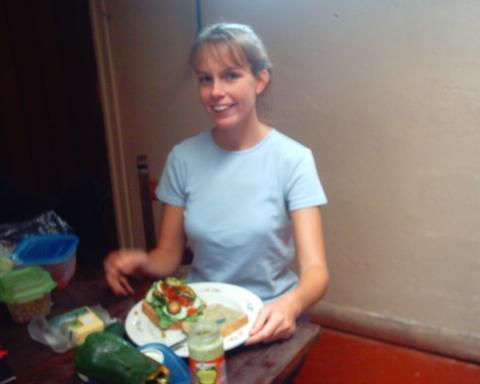What is this woman going to eat?
Choose the right answer from the provided options to respond to the question.
Options: Steak, burrito, taco, sandwich. Sandwich. 